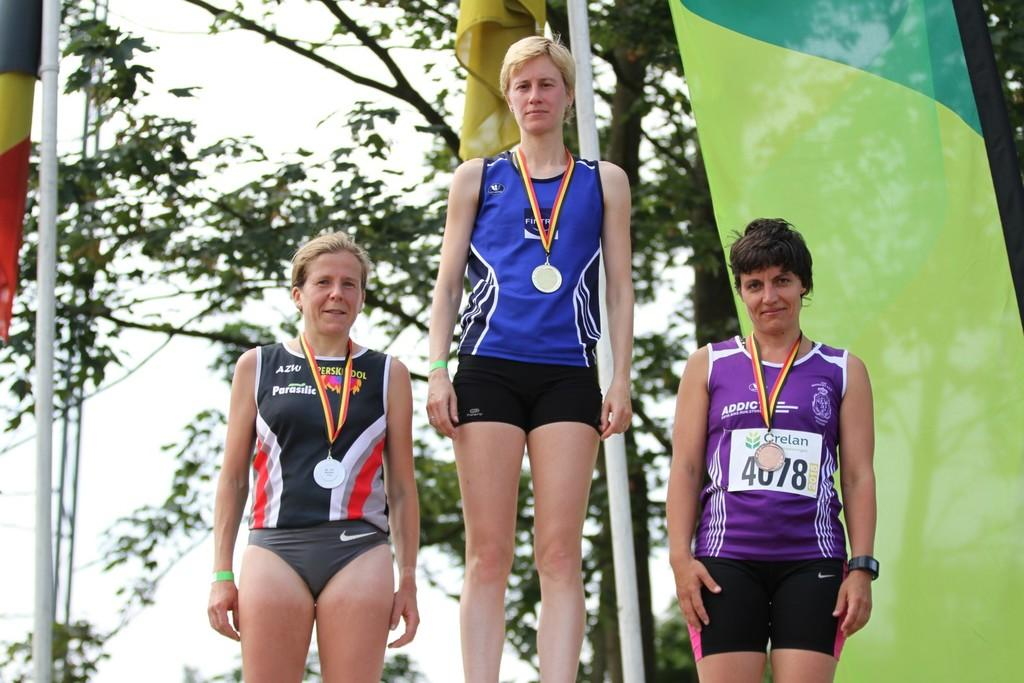Provide a one-sentence caption for the provided image. AZW logo on a black jersey shirt and a Crelan logo on a purple jersey. 